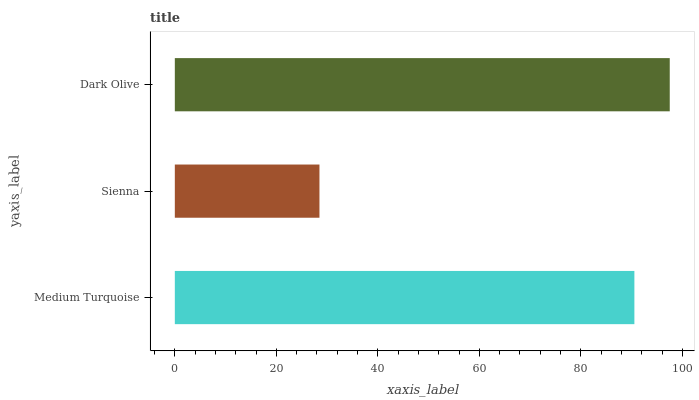Is Sienna the minimum?
Answer yes or no. Yes. Is Dark Olive the maximum?
Answer yes or no. Yes. Is Dark Olive the minimum?
Answer yes or no. No. Is Sienna the maximum?
Answer yes or no. No. Is Dark Olive greater than Sienna?
Answer yes or no. Yes. Is Sienna less than Dark Olive?
Answer yes or no. Yes. Is Sienna greater than Dark Olive?
Answer yes or no. No. Is Dark Olive less than Sienna?
Answer yes or no. No. Is Medium Turquoise the high median?
Answer yes or no. Yes. Is Medium Turquoise the low median?
Answer yes or no. Yes. Is Dark Olive the high median?
Answer yes or no. No. Is Dark Olive the low median?
Answer yes or no. No. 